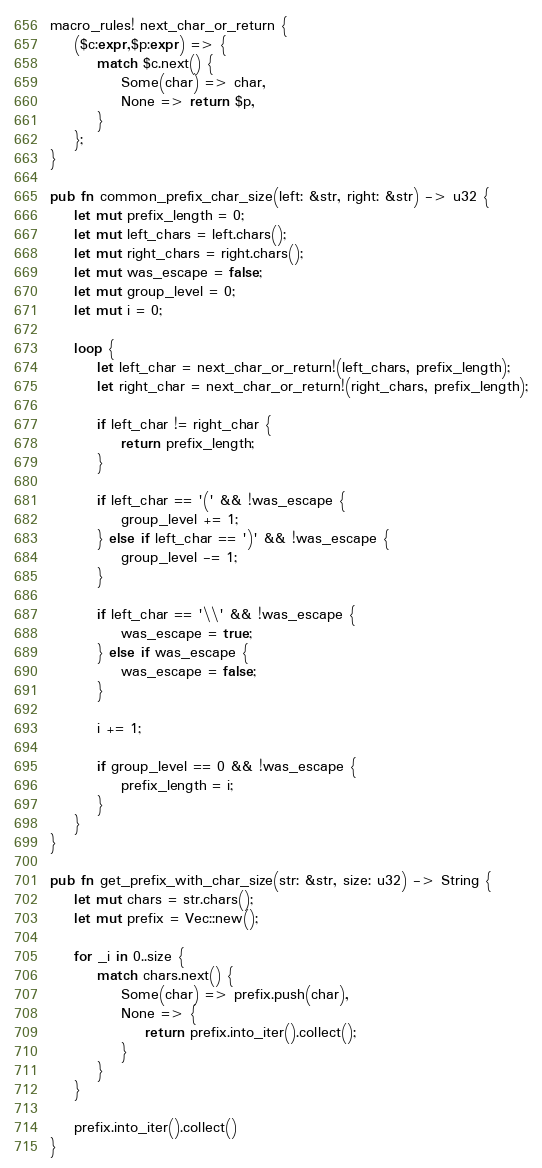<code> <loc_0><loc_0><loc_500><loc_500><_Rust_>macro_rules! next_char_or_return {
    ($c:expr,$p:expr) => {
        match $c.next() {
            Some(char) => char,
            None => return $p,
        }
    };
}

pub fn common_prefix_char_size(left: &str, right: &str) -> u32 {
    let mut prefix_length = 0;
    let mut left_chars = left.chars();
    let mut right_chars = right.chars();
    let mut was_escape = false;
    let mut group_level = 0;
    let mut i = 0;

    loop {
        let left_char = next_char_or_return!(left_chars, prefix_length);
        let right_char = next_char_or_return!(right_chars, prefix_length);

        if left_char != right_char {
            return prefix_length;
        }

        if left_char == '(' && !was_escape {
            group_level += 1;
        } else if left_char == ')' && !was_escape {
            group_level -= 1;
        }

        if left_char == '\\' && !was_escape {
            was_escape = true;
        } else if was_escape {
            was_escape = false;
        }

        i += 1;

        if group_level == 0 && !was_escape {
            prefix_length = i;
        }
    }
}

pub fn get_prefix_with_char_size(str: &str, size: u32) -> String {
    let mut chars = str.chars();
    let mut prefix = Vec::new();

    for _i in 0..size {
        match chars.next() {
            Some(char) => prefix.push(char),
            None => {
                return prefix.into_iter().collect();
            }
        }
    }

    prefix.into_iter().collect()
}
</code> 